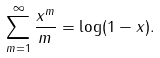Convert formula to latex. <formula><loc_0><loc_0><loc_500><loc_500>\sum _ { m = 1 } ^ { \infty } { \frac { x ^ { m } } { m } } = \log ( 1 - x ) .</formula> 